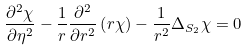Convert formula to latex. <formula><loc_0><loc_0><loc_500><loc_500>\frac { \partial ^ { 2 } \chi } { \partial \eta ^ { 2 } } - \frac { 1 } { r } \frac { \partial ^ { 2 } } { \partial r ^ { 2 } } \left ( r \chi \right ) - \frac { 1 } { r ^ { 2 } } \Delta _ { S _ { 2 } } \chi = 0</formula> 